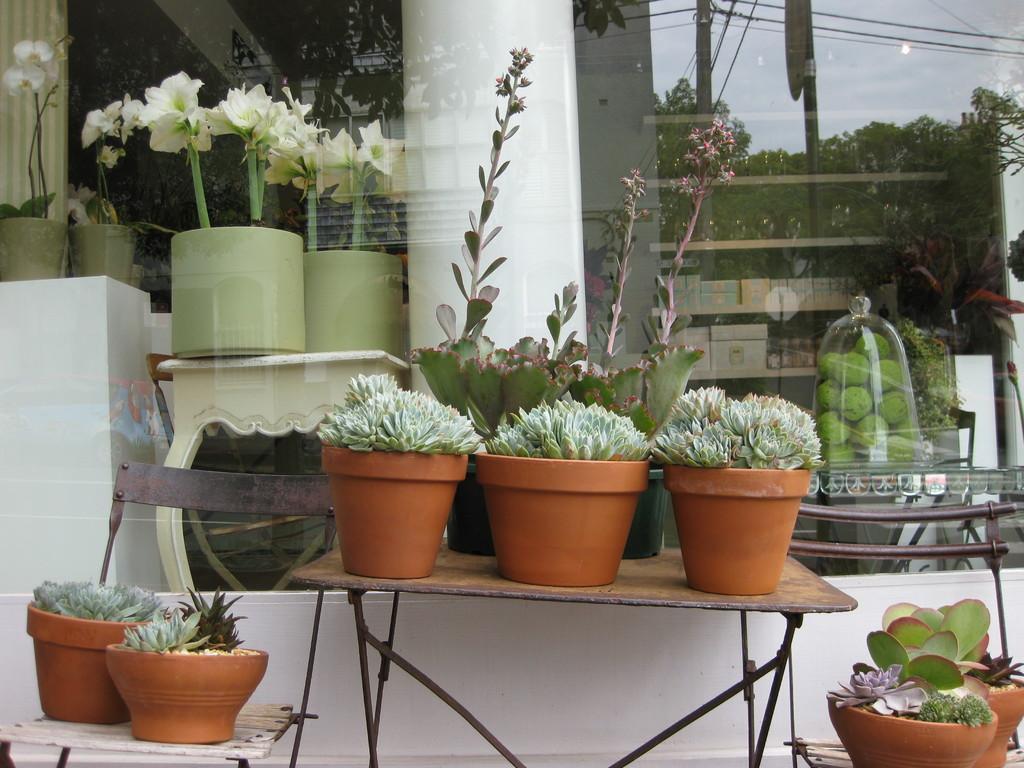Could you give a brief overview of what you see in this image? In this image we can see there is a table and chairs and on them there are plants. In the background we can see a glass door. Inside the glass door there are plants, racks and also the reflection of the poles, trees and objects. 